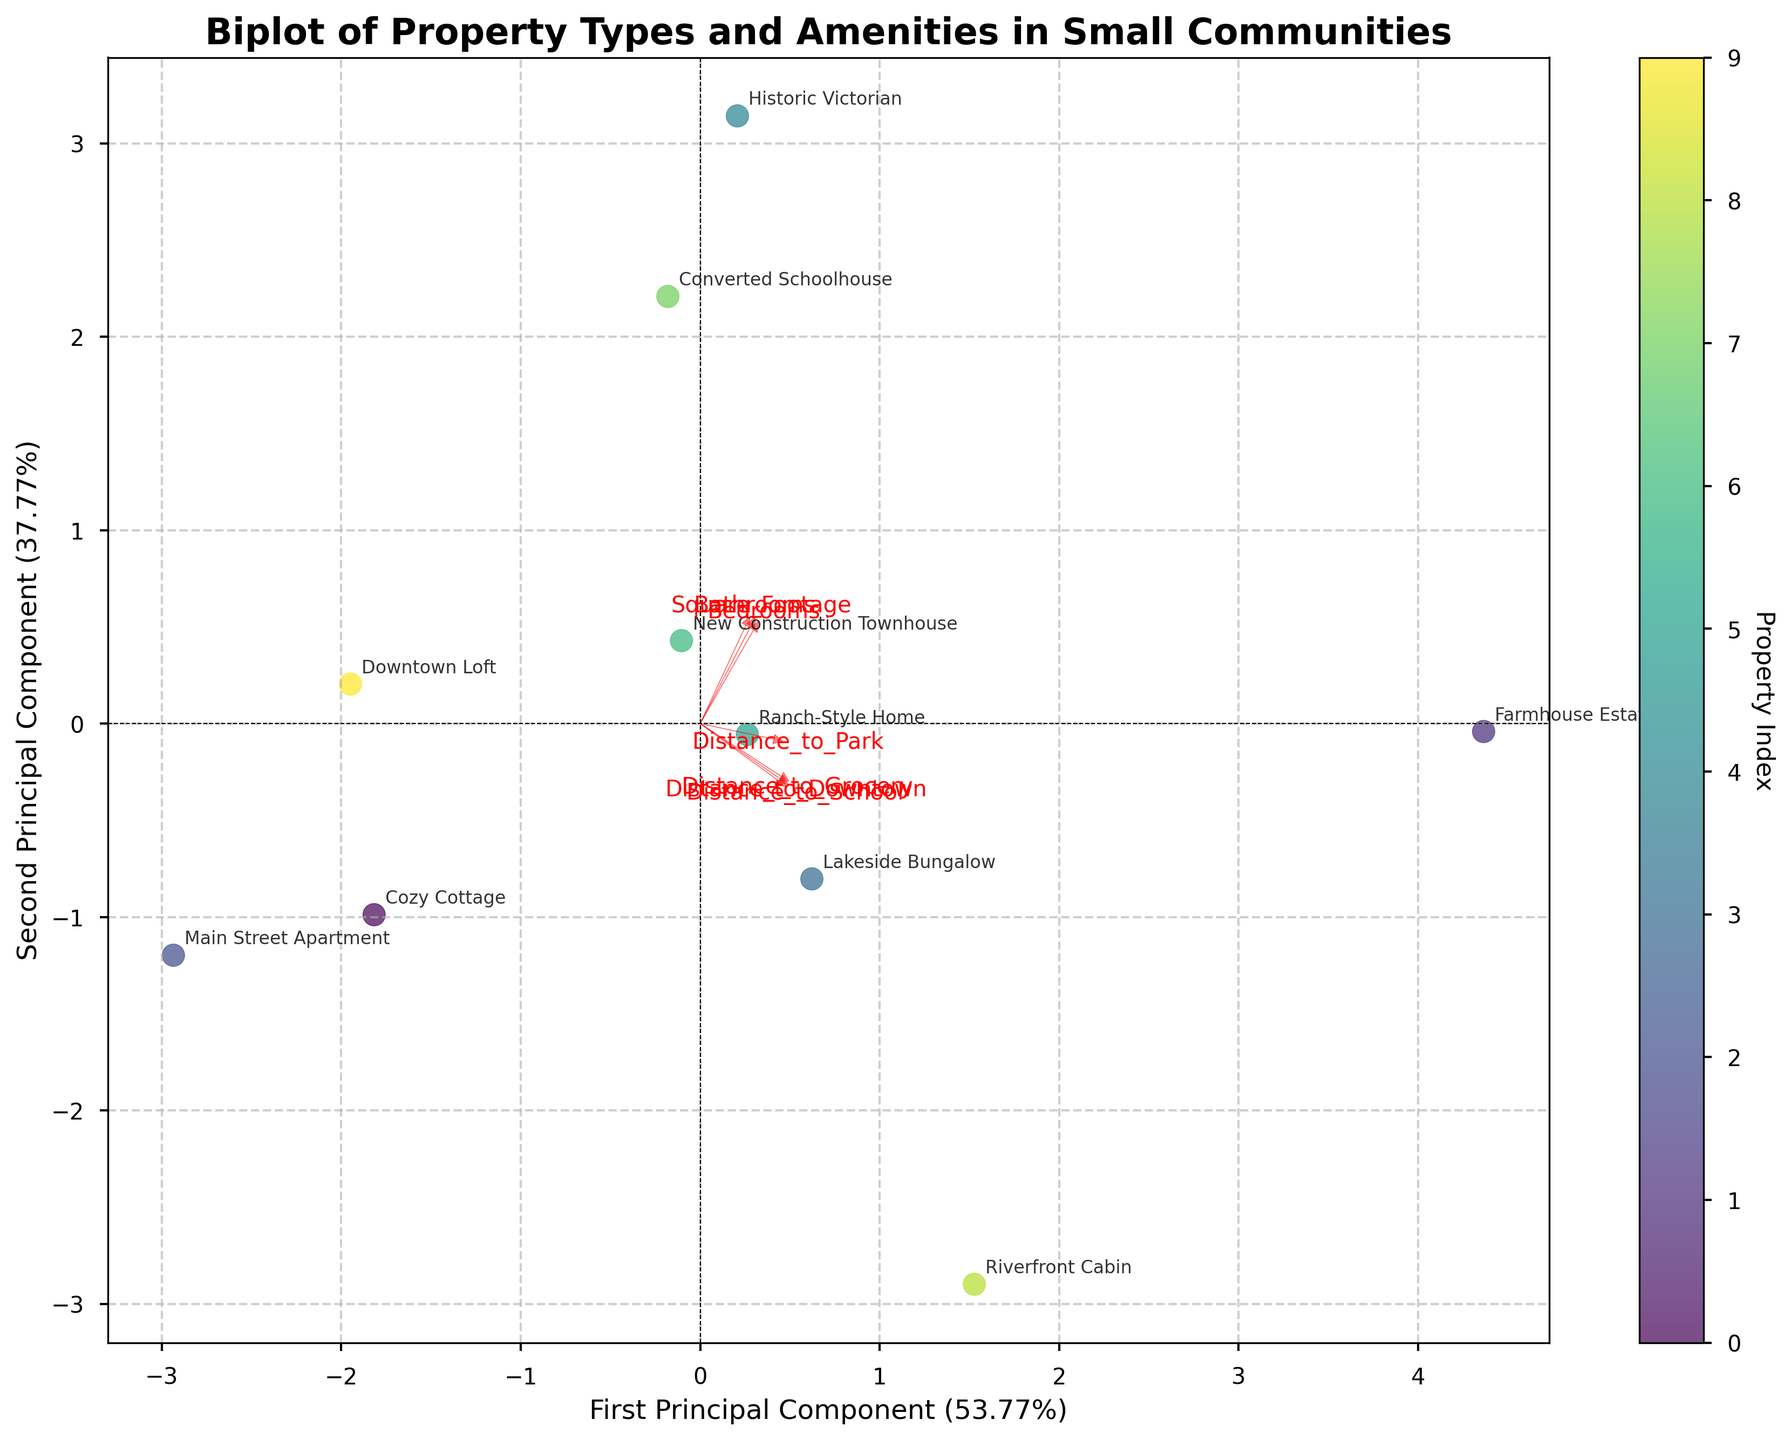Which property is closest to the downtown area? The biplot shows the position of properties with respect to the first and second principal components, derived from distance and other features. The "Main Street Apartment" is placed closest to the origin, indicating it is nearest to the downtown area.
Answer: Main Street Apartment Which feature vector has the longest arrow in the biplot? The arrows in the biplot represent the contribution of each feature to the principal components. The "Square_Footage" arrow is the longest, showing it has the highest variance among the data and contributes most significantly to the principal components.
Answer: Square_Footage Which two properties appear to be the most similar based on the biplot? By visually comparing the proximity of the data points in the biplot, "New Construction Townhouse" and "Ranch-Style Home" are closest to each other, suggesting they have similar features and amenity distances.
Answer: New Construction Townhouse and Ranch-Style Home Which principal component explains more variance in the data? The first principal component (PC1) has a larger percentage indicated on its axis label than the second principal component (PC2). By inspecting the biplot, PC1 explains more variance.
Answer: First principal component Which property types are located in less urban areas based on the distance plotted? Properties further from the origin generally reflect greater distances from amenities like downtown. "Farmhouse Estate" and "Riverfront Cabin" fall in the outer regions, indicating they are in more rural settings.
Answer: Farmhouse Estate and Riverfront Cabin Which feature contributes the least to the second principal component but significantly to the first? In the biplot, "Bedrooms" has a noticeable projection along the first principal component axis, but a small projection along the second principal component axis, indicating it contributes more to the first component.
Answer: Bedrooms How many principal components are plotted in the biplot? The biplot displays two principal components, as represented by the two axes titled "First Principal Component" and "Second Principal Component".
Answer: Two What percentage of variance is explained by the second principal component? The axis label for the second principal component includes a percentage that indicates the variance explained. By looking at this label, we can see it is approximately [insert percentage from the figure].
Answer: [Insert percentage from the figure] Which property has the most amount of square footage? Based on the position along the "Square_Footage" feature vector, "Historic Victorian" lies furthest in the direction of the arrow, suggesting it has the highest square footage.
Answer: Historic Victorian Based on the plot, can we infer if the number of bathrooms affects distances to amenities significantly? The "Bathrooms" feature vector has relatively long arrows in both principal components, indicating it has a notable but not the most significant contribution to the variance in distances to amenities.
Answer: Yes, but not the most significant 